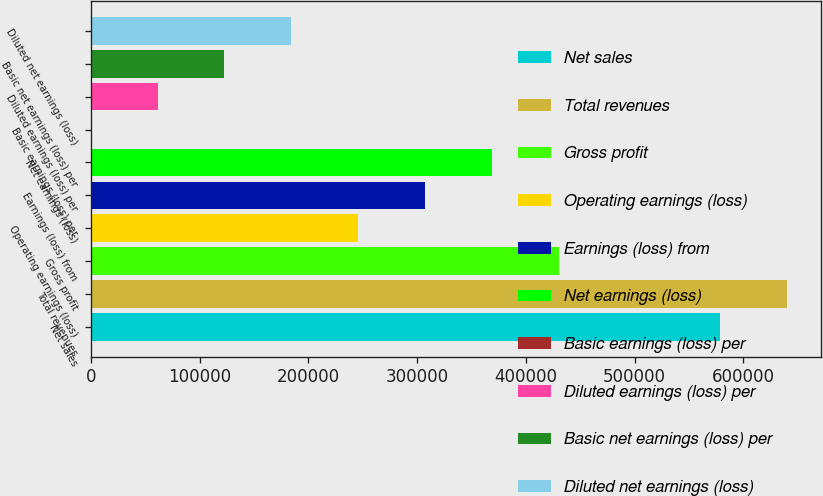Convert chart. <chart><loc_0><loc_0><loc_500><loc_500><bar_chart><fcel>Net sales<fcel>Total revenues<fcel>Gross profit<fcel>Operating earnings (loss)<fcel>Earnings (loss) from<fcel>Net earnings (loss)<fcel>Basic earnings (loss) per<fcel>Diluted earnings (loss) per<fcel>Basic net earnings (loss) per<fcel>Diluted net earnings (loss)<nl><fcel>578189<fcel>639652<fcel>430239<fcel>245851<fcel>307314<fcel>368776<fcel>0.2<fcel>61462.9<fcel>122926<fcel>184388<nl></chart> 